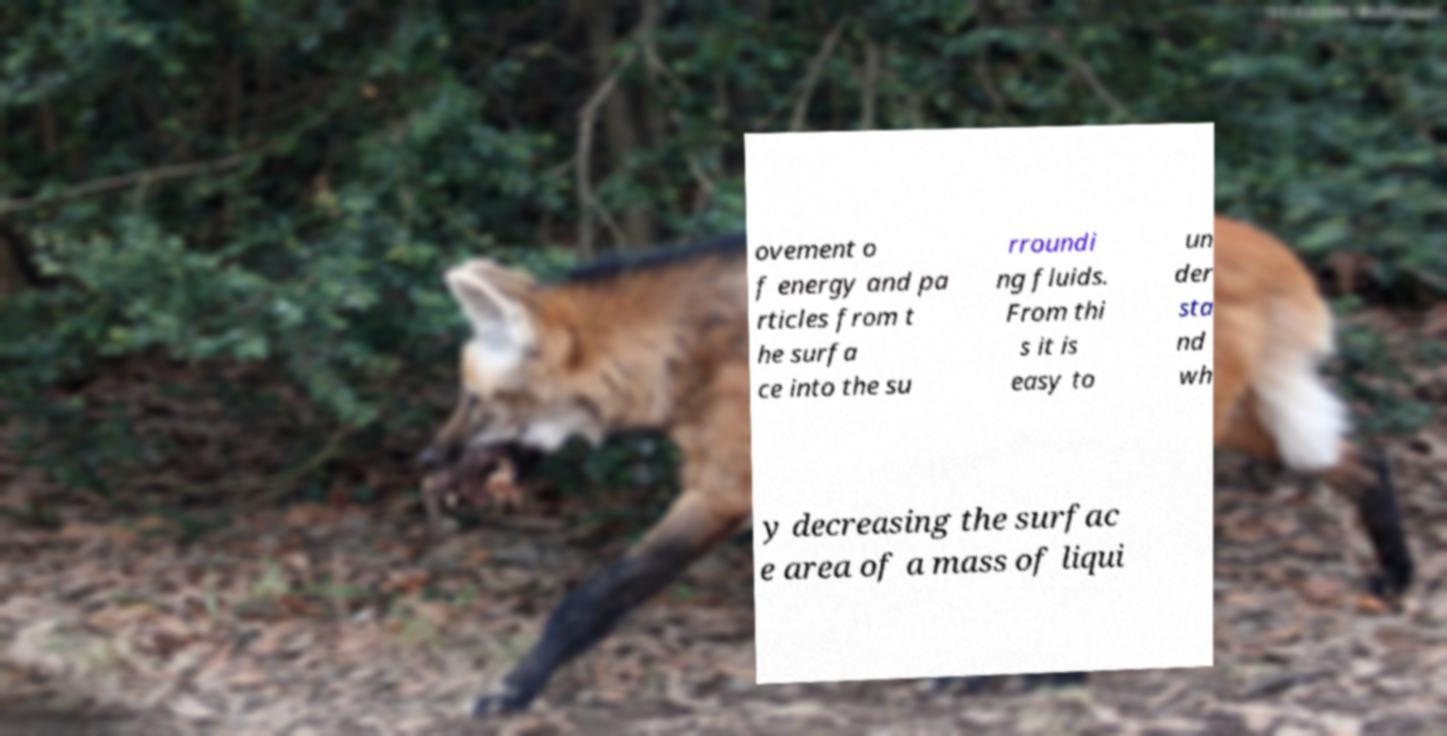Please read and relay the text visible in this image. What does it say? ovement o f energy and pa rticles from t he surfa ce into the su rroundi ng fluids. From thi s it is easy to un der sta nd wh y decreasing the surfac e area of a mass of liqui 